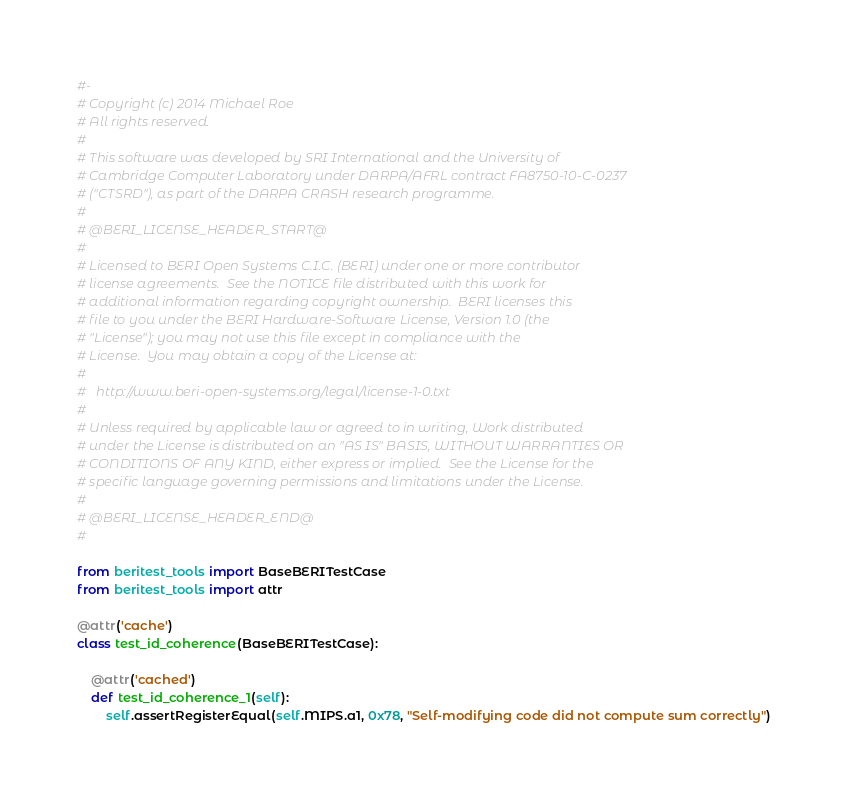<code> <loc_0><loc_0><loc_500><loc_500><_Python_>#-
# Copyright (c) 2014 Michael Roe
# All rights reserved.
#
# This software was developed by SRI International and the University of
# Cambridge Computer Laboratory under DARPA/AFRL contract FA8750-10-C-0237
# ("CTSRD"), as part of the DARPA CRASH research programme.
#
# @BERI_LICENSE_HEADER_START@
#
# Licensed to BERI Open Systems C.I.C. (BERI) under one or more contributor
# license agreements.  See the NOTICE file distributed with this work for
# additional information regarding copyright ownership.  BERI licenses this
# file to you under the BERI Hardware-Software License, Version 1.0 (the
# "License"); you may not use this file except in compliance with the
# License.  You may obtain a copy of the License at:
#
#   http://www.beri-open-systems.org/legal/license-1-0.txt
#
# Unless required by applicable law or agreed to in writing, Work distributed
# under the License is distributed on an "AS IS" BASIS, WITHOUT WARRANTIES OR
# CONDITIONS OF ANY KIND, either express or implied.  See the License for the
# specific language governing permissions and limitations under the License.
#
# @BERI_LICENSE_HEADER_END@
#

from beritest_tools import BaseBERITestCase
from beritest_tools import attr

@attr('cache')
class test_id_coherence(BaseBERITestCase):

    @attr('cached')
    def test_id_coherence_1(self):
        self.assertRegisterEqual(self.MIPS.a1, 0x78, "Self-modifying code did not compute sum correctly")
</code> 